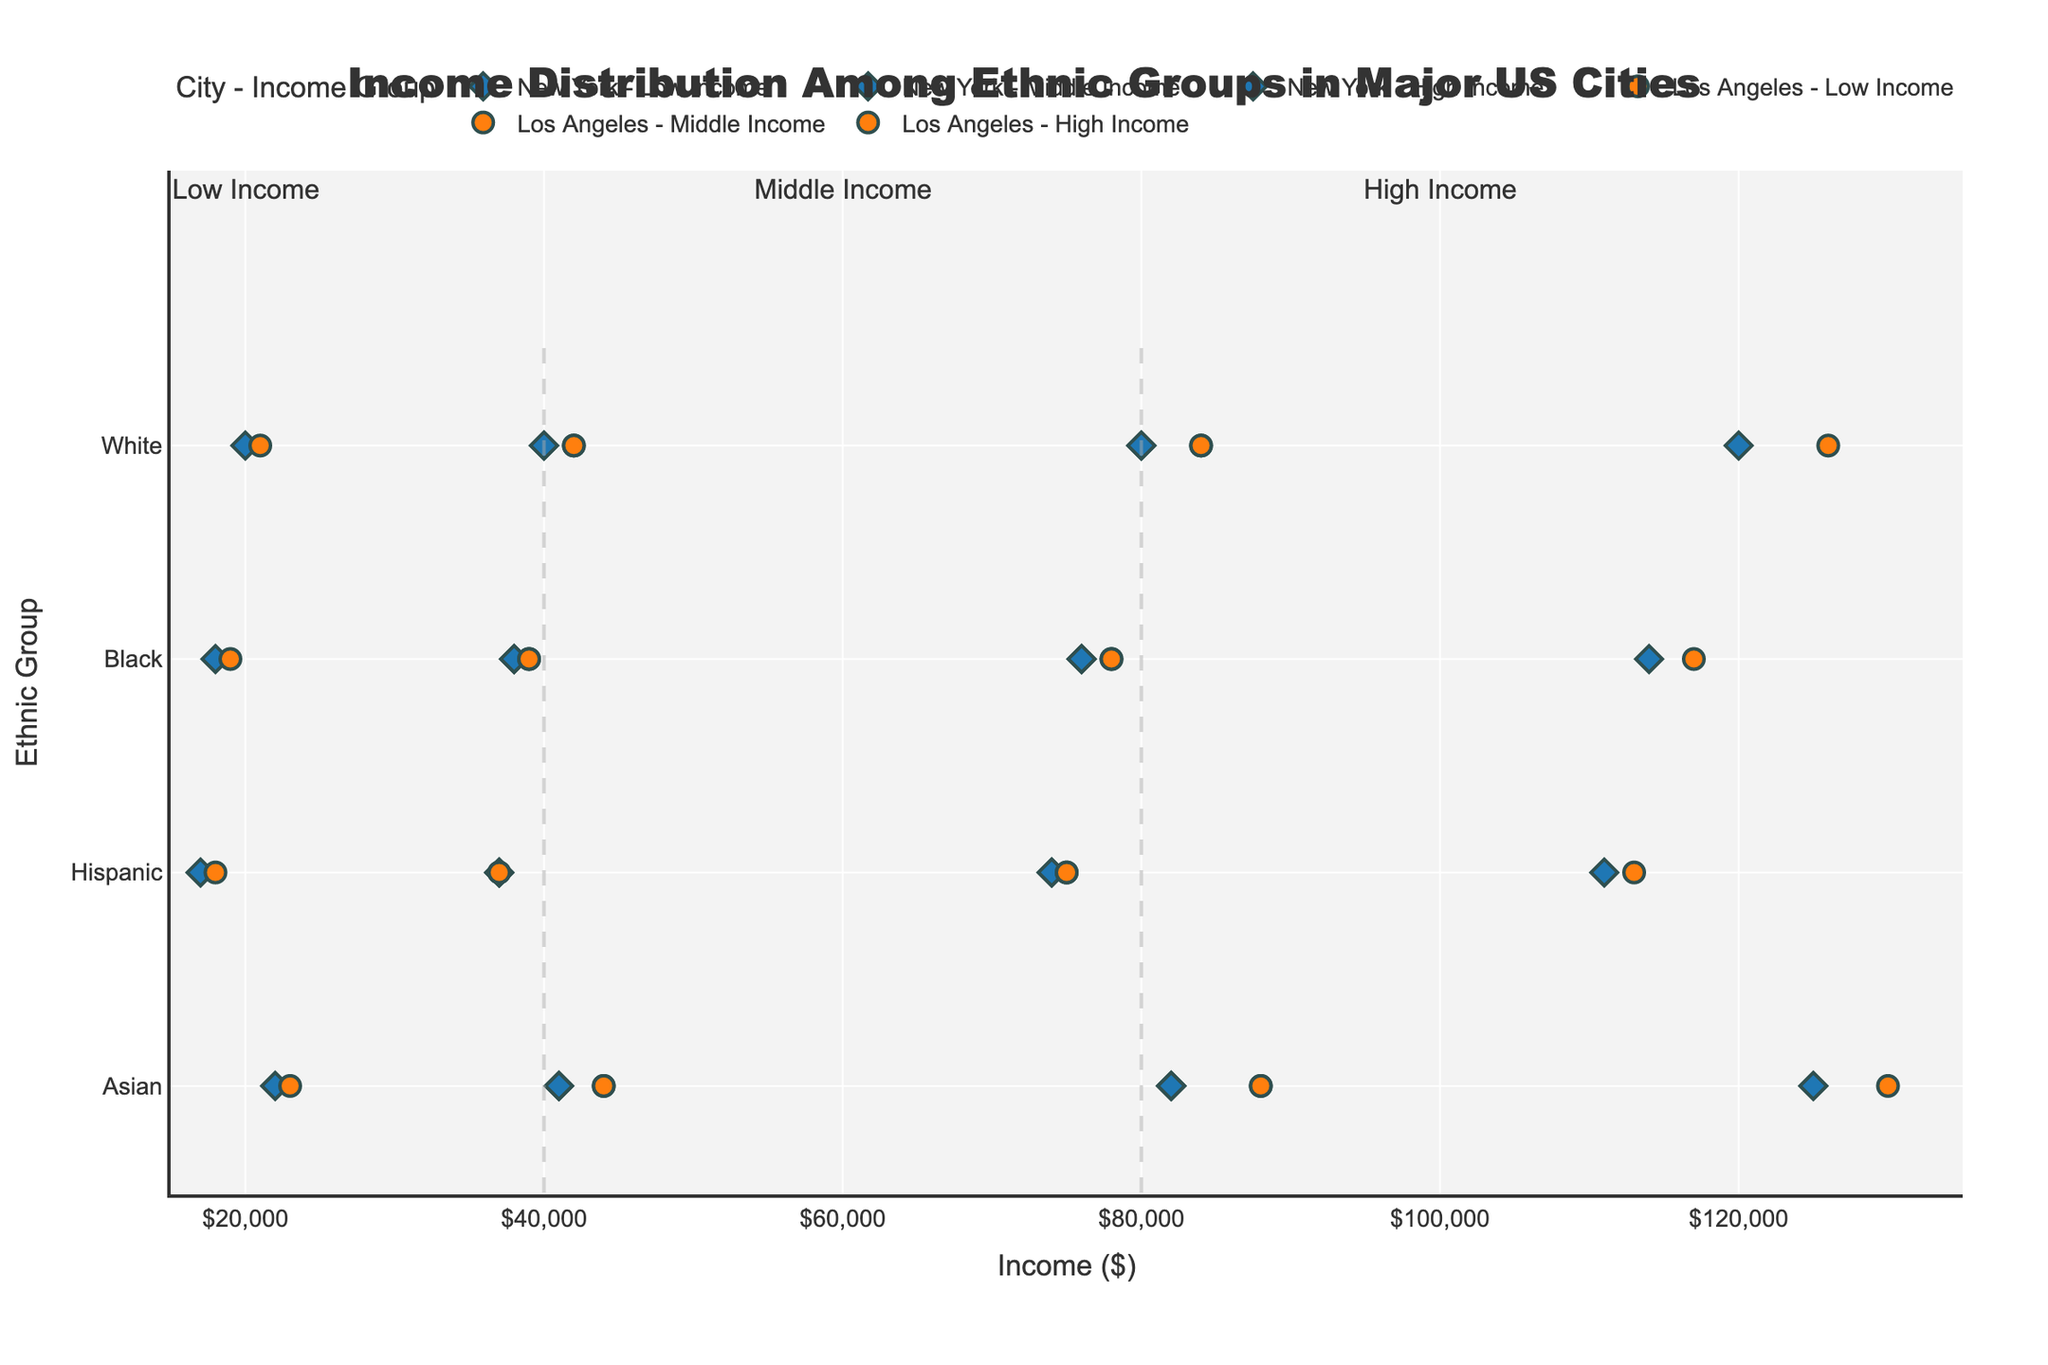What is the title of the figure? The title of the figure is typically displayed prominently at the top of the graph. Here, it is "Income Distribution Among Ethnic Groups in Major US Cities."
Answer: Income Distribution Among Ethnic Groups in Major US Cities Which city has the highest maximum income among Asian ethnic groups, and what is that income? Observing the maximum income for Asian ethnic groups across the cities, the highest maximum income is in Los Angeles, which is $130,000.
Answer: Los Angeles, $130,000 What are the minimum and maximum incomes for the Hispanic ethnic group in New York within the high-income category? The New York high-income category for the Hispanic group shows a minimum income of $74,000 and a maximum income of $111,000.
Answer: $74,000, $111,000 Compare the maximum income of the Black ethnic group between New York and Los Angeles in the low-income category. Which city has a higher value, and what is the difference? New York's maximum income for the Black ethnic group in the low-income category is $38,000, while Los Angeles' is $39,000. Los Angeles has a higher value by $1,000.
Answer: Los Angeles, $1,000 What visual indicator differentiates the cities on the plot? Cities are differentiated by marker shapes and colors. New York uses diamond shapes with a specific color, while Los Angeles uses circle shapes with a different color.
Answer: Marker shapes and colors How does the income distribution of the Asian ethnic group in New York compare to the White ethnic group within the middle-income category? The income range for Asians in New York within the middle-income category is from $41,000 to $82,000. For Whites, it is from $40,000 to $80,000. Asians have both a higher minimum and maximum income in this category.
Answer: Asians have higher minimum and maximum incomes Calculate the average minimum income for the Hispanic ethnic group across both cities in the low-income category. For Hispanics in the low-income category, the minimum incomes are $17,000 (New York) and $18,000 (Los Angeles). The average is (17,000 + 18,000) / 2, which is $17,500.
Answer: $17,500 How many income ranges are indicated by dashed vertical lines in the figure, and what do they signify? There are two dashed vertical lines in the figure. They signify the income thresholds for distinguishing low, middle, and high-income groups.
Answer: Two, income thresholds Which ethnic group has the largest difference between the minimum and maximum incomes in Los Angeles within the high-income category, and what is the difference? The Asian ethnic group in Los Angeles has the largest difference in the high-income category. The difference is $130,000 - $88,000 = $42,000.
Answer: Asian, $42,000 